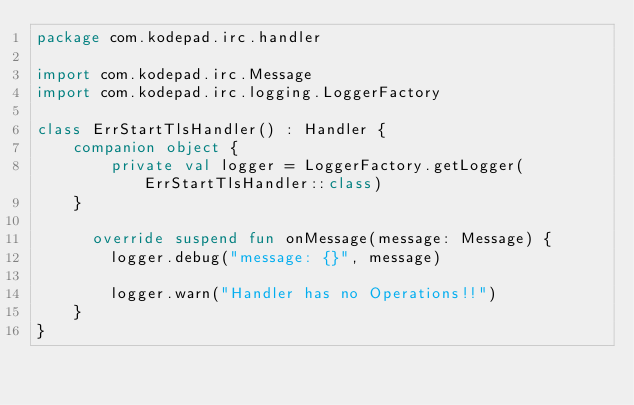Convert code to text. <code><loc_0><loc_0><loc_500><loc_500><_Kotlin_>package com.kodepad.irc.handler

import com.kodepad.irc.Message
import com.kodepad.irc.logging.LoggerFactory

class ErrStartTlsHandler() : Handler {
    companion object {
        private val logger = LoggerFactory.getLogger(ErrStartTlsHandler::class)
    }

      override suspend fun onMessage(message: Message) {
        logger.debug("message: {}", message)
        
        logger.warn("Handler has no Operations!!")
    }
}</code> 